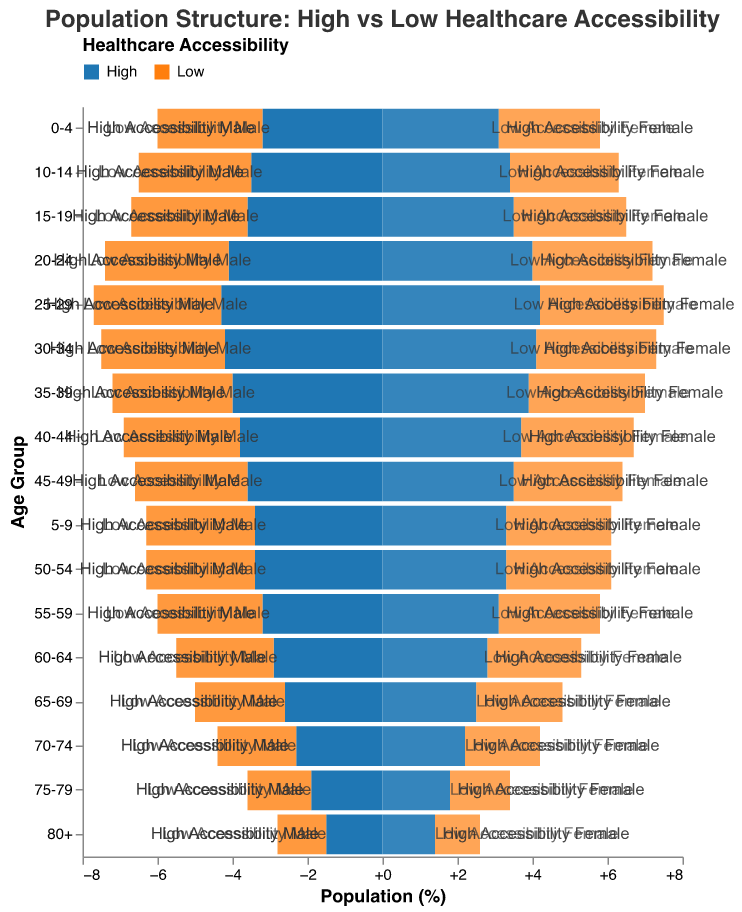What is the title of the figure? The title is displayed at the top of the figure, indicating the subject matter.
Answer: Population Structure: High vs Low Healthcare Accessibility What is the percentage of males aged 25-29 in areas with high healthcare accessibility? Find the bar representing males aged 25-29 in high healthcare accessibility areas. The value is displayed next to the bar.
Answer: 4.3% Which age group has the highest population percentage in areas with high healthcare accessibility? Compare the bars for each age group within high healthcare accessibility to find the one with the highest value.
Answer: 25-29 How does the population percentage of females aged 0-4 compare between high and low healthcare accessibility areas? Find the bars representing females aged 0-4 for both high and low healthcare accessibility and compare their lengths.
Answer: High healthcare accessibility has 3.1%, Low healthcare accessibility has 2.7% What is the difference in population percentage of males aged 20-24 between high and low healthcare accessibility areas? Subtract the value for low healthcare accessibility males aged 20-24 from the value for high healthcare accessibility.
Answer: 0.8% What is the sum of the population percentages of males aged 0-4 and females aged 0-4 in areas with low healthcare accessibility? Add the values for low healthcare accessibility males aged 0-4 (2.8%) and females aged 0-4 (2.7%).
Answer: 5.5% In which age group is the population percentage of females higher than that of males in areas with high healthcare accessibility? Compare the bars for males and females in each age group within high healthcare accessibility to find where the females' bar is longer.
Answer: None What is the average population percentage for ages 30-34 in areas with high healthcare accessibility? Take the values for males and females aged 30-34 in high healthcare accessibility, add them, and divide by 2. (4.2% + 4.1%) / 2
Answer: 4.15% At which age do populations start to decrease more significantly in areas with both high and low healthcare accessibility? Look for the age group where a noticeable decline begins in the length of the bars for both high and low healthcare accessibility.
Answer: 60-64 What is the difference in population percentage of females aged 70-74 between high and low healthcare accessibility areas? Subtract the value for low healthcare accessibility females aged 70-74 from the value for high healthcare accessibility.
Answer: 0.2% 